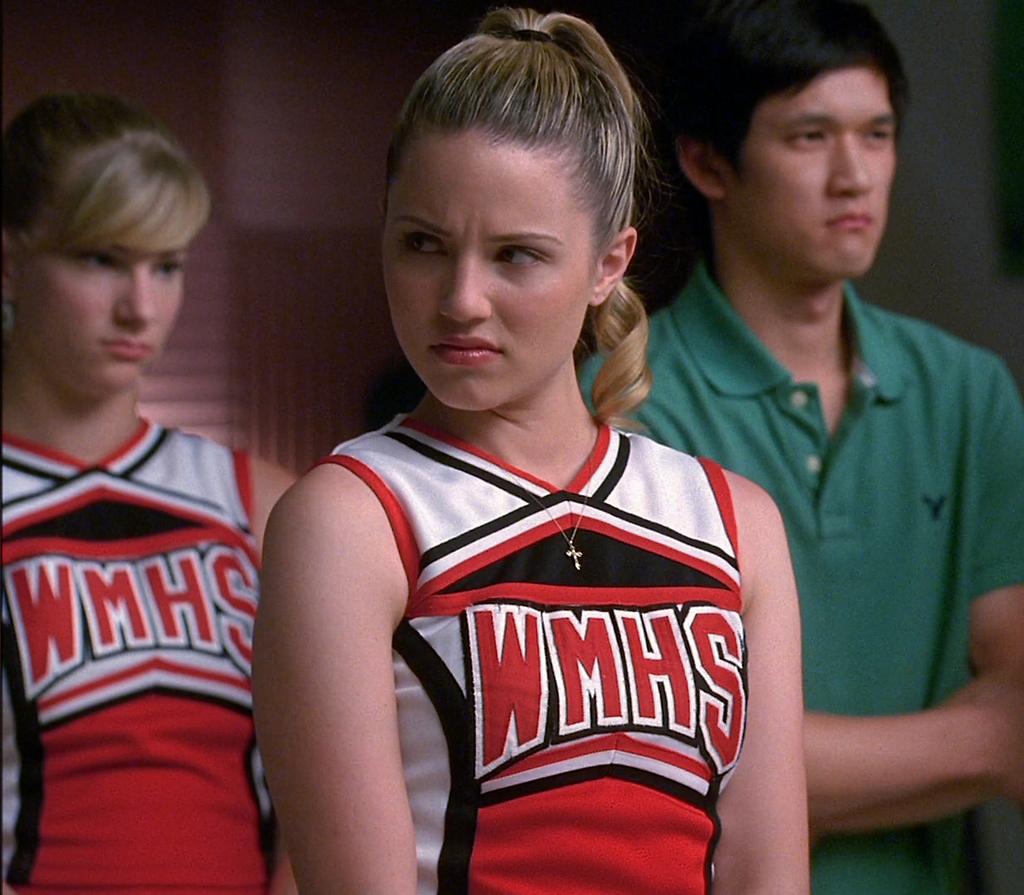What color are the letters?
Your response must be concise. Red. 